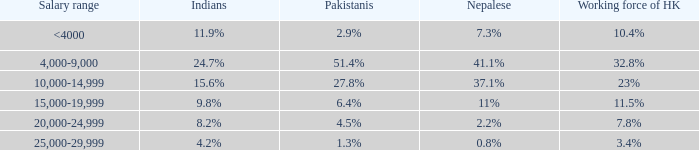If the working force of HK is 32.8%, what are the Pakistanis' %?  51.4%. 